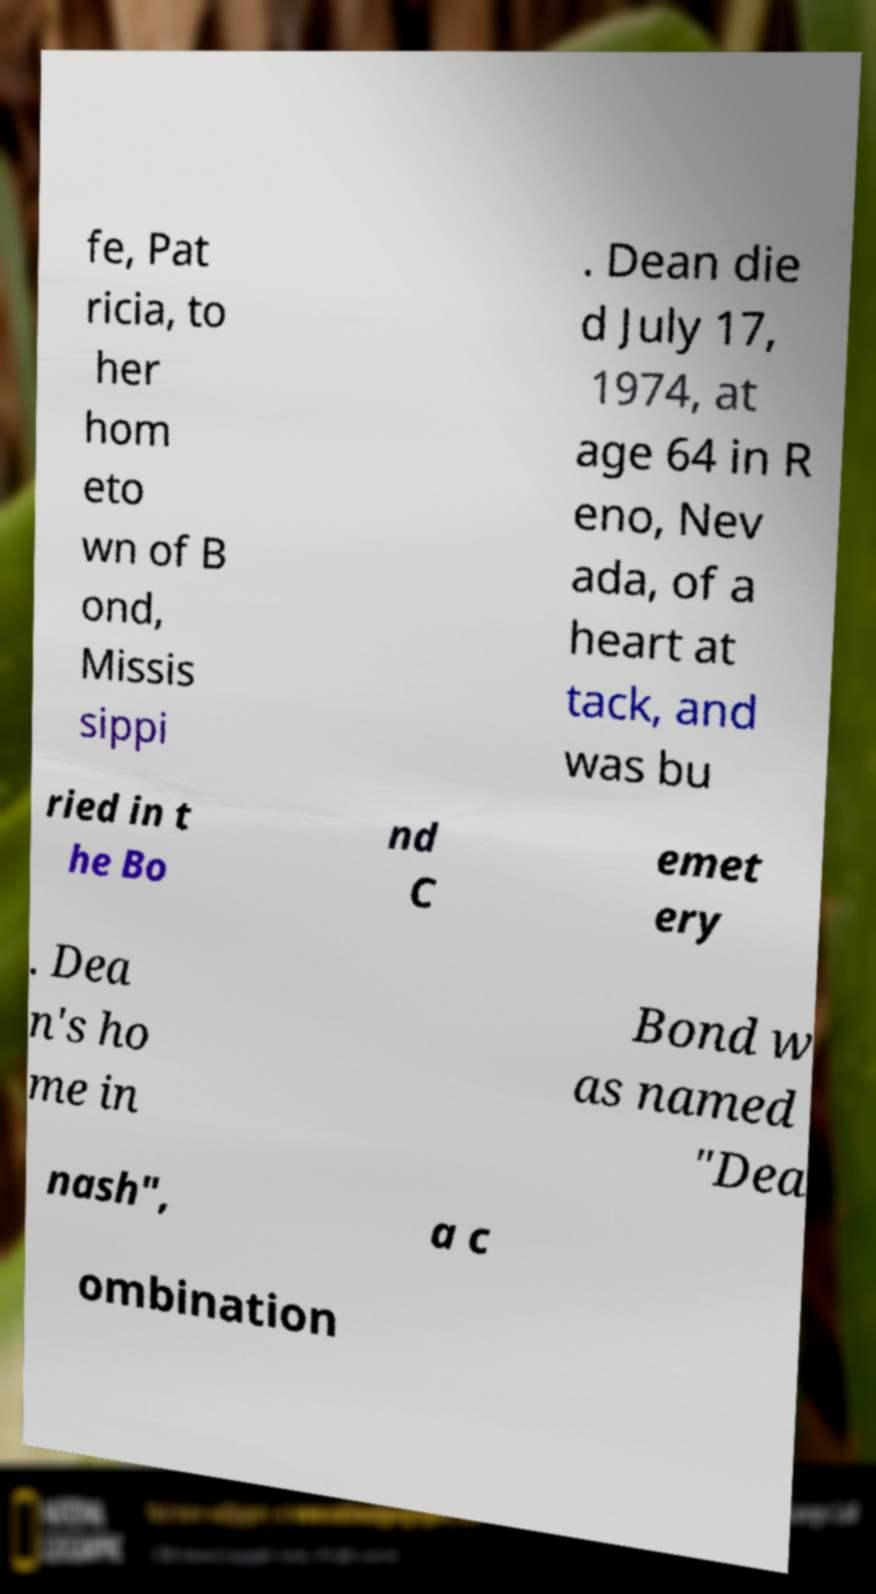Could you extract and type out the text from this image? fe, Pat ricia, to her hom eto wn of B ond, Missis sippi . Dean die d July 17, 1974, at age 64 in R eno, Nev ada, of a heart at tack, and was bu ried in t he Bo nd C emet ery . Dea n's ho me in Bond w as named "Dea nash", a c ombination 